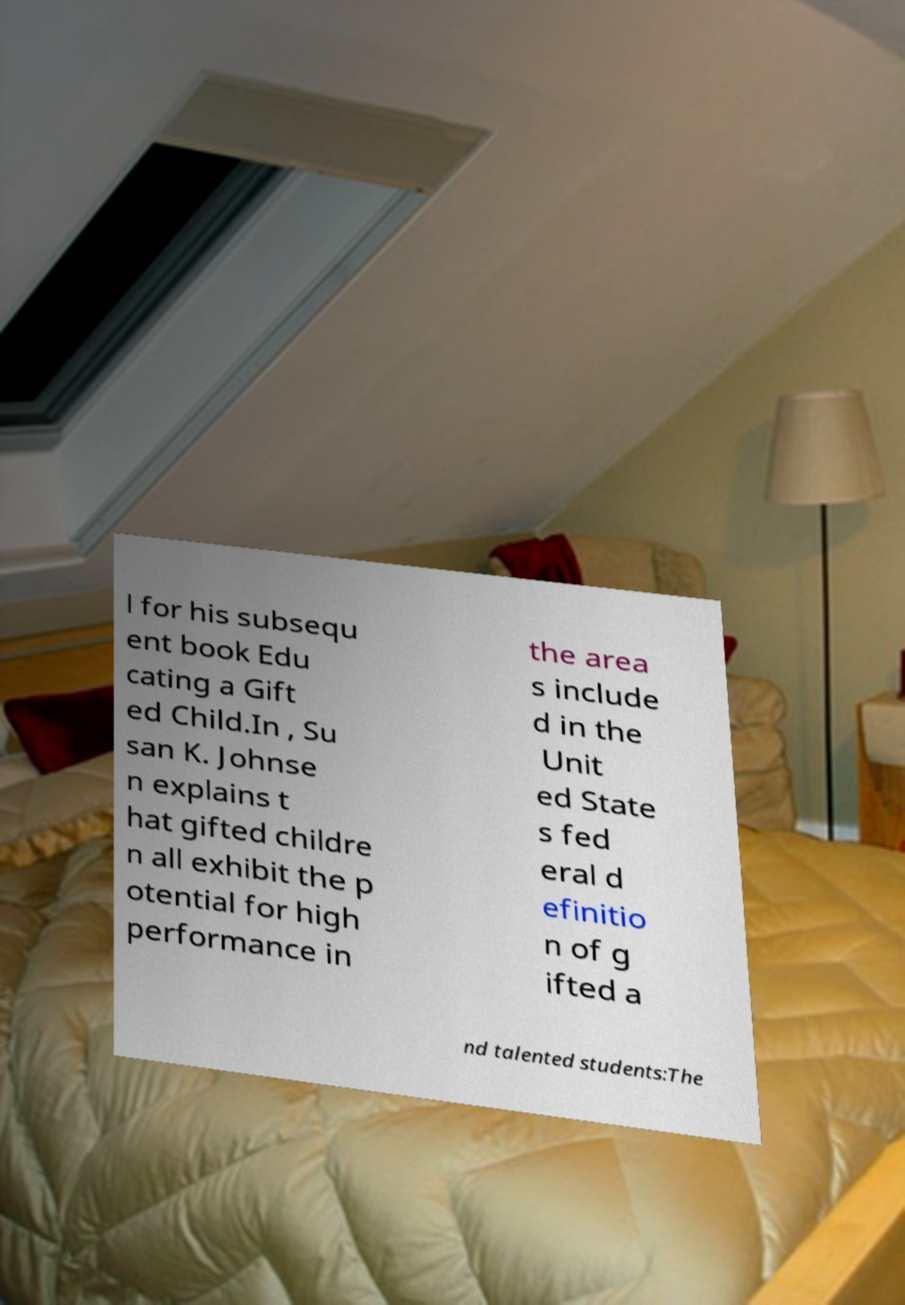There's text embedded in this image that I need extracted. Can you transcribe it verbatim? l for his subsequ ent book Edu cating a Gift ed Child.In , Su san K. Johnse n explains t hat gifted childre n all exhibit the p otential for high performance in the area s include d in the Unit ed State s fed eral d efinitio n of g ifted a nd talented students:The 